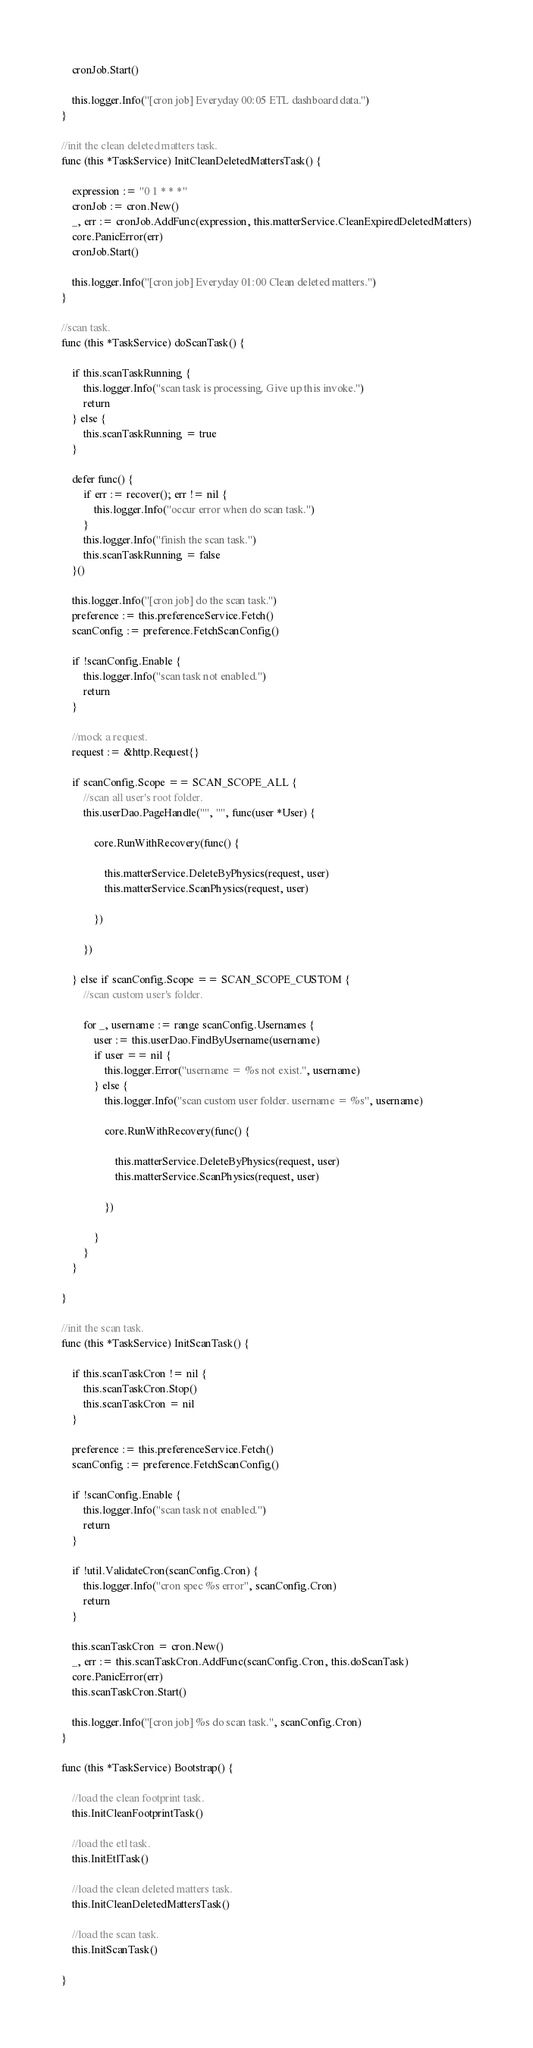Convert code to text. <code><loc_0><loc_0><loc_500><loc_500><_Go_>	cronJob.Start()

	this.logger.Info("[cron job] Everyday 00:05 ETL dashboard data.")
}

//init the clean deleted matters task.
func (this *TaskService) InitCleanDeletedMattersTask() {

	expression := "0 1 * * *"
	cronJob := cron.New()
	_, err := cronJob.AddFunc(expression, this.matterService.CleanExpiredDeletedMatters)
	core.PanicError(err)
	cronJob.Start()

	this.logger.Info("[cron job] Everyday 01:00 Clean deleted matters.")
}

//scan task.
func (this *TaskService) doScanTask() {

	if this.scanTaskRunning {
		this.logger.Info("scan task is processing. Give up this invoke.")
		return
	} else {
		this.scanTaskRunning = true
	}

	defer func() {
		if err := recover(); err != nil {
			this.logger.Info("occur error when do scan task.")
		}
		this.logger.Info("finish the scan task.")
		this.scanTaskRunning = false
	}()

	this.logger.Info("[cron job] do the scan task.")
	preference := this.preferenceService.Fetch()
	scanConfig := preference.FetchScanConfig()

	if !scanConfig.Enable {
		this.logger.Info("scan task not enabled.")
		return
	}

	//mock a request.
	request := &http.Request{}

	if scanConfig.Scope == SCAN_SCOPE_ALL {
		//scan all user's root folder.
		this.userDao.PageHandle("", "", func(user *User) {

			core.RunWithRecovery(func() {

				this.matterService.DeleteByPhysics(request, user)
				this.matterService.ScanPhysics(request, user)

			})

		})

	} else if scanConfig.Scope == SCAN_SCOPE_CUSTOM {
		//scan custom user's folder.

		for _, username := range scanConfig.Usernames {
			user := this.userDao.FindByUsername(username)
			if user == nil {
				this.logger.Error("username = %s not exist.", username)
			} else {
				this.logger.Info("scan custom user folder. username = %s", username)

				core.RunWithRecovery(func() {

					this.matterService.DeleteByPhysics(request, user)
					this.matterService.ScanPhysics(request, user)

				})

			}
		}
	}

}

//init the scan task.
func (this *TaskService) InitScanTask() {

	if this.scanTaskCron != nil {
		this.scanTaskCron.Stop()
		this.scanTaskCron = nil
	}

	preference := this.preferenceService.Fetch()
	scanConfig := preference.FetchScanConfig()

	if !scanConfig.Enable {
		this.logger.Info("scan task not enabled.")
		return
	}

	if !util.ValidateCron(scanConfig.Cron) {
		this.logger.Info("cron spec %s error", scanConfig.Cron)
		return
	}

	this.scanTaskCron = cron.New()
	_, err := this.scanTaskCron.AddFunc(scanConfig.Cron, this.doScanTask)
	core.PanicError(err)
	this.scanTaskCron.Start()

	this.logger.Info("[cron job] %s do scan task.", scanConfig.Cron)
}

func (this *TaskService) Bootstrap() {

	//load the clean footprint task.
	this.InitCleanFootprintTask()

	//load the etl task.
	this.InitEtlTask()

	//load the clean deleted matters task.
	this.InitCleanDeletedMattersTask()

	//load the scan task.
	this.InitScanTask()

}
</code> 